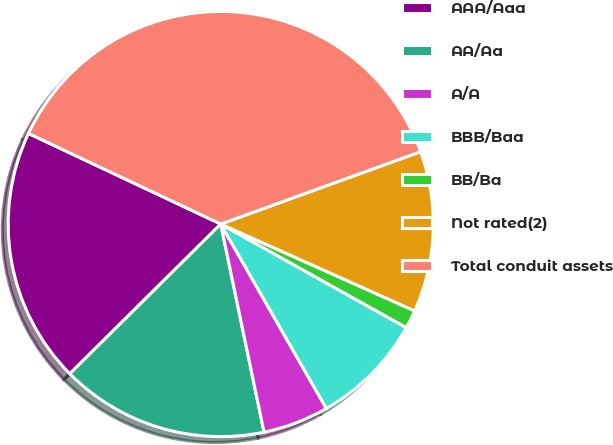<chart> <loc_0><loc_0><loc_500><loc_500><pie_chart><fcel>AAA/Aaa<fcel>AA/Aa<fcel>A/A<fcel>BBB/Baa<fcel>BB/Ba<fcel>Not rated(2)<fcel>Total conduit assets<nl><fcel>19.44%<fcel>15.83%<fcel>5.01%<fcel>8.62%<fcel>1.4%<fcel>12.23%<fcel>37.46%<nl></chart> 